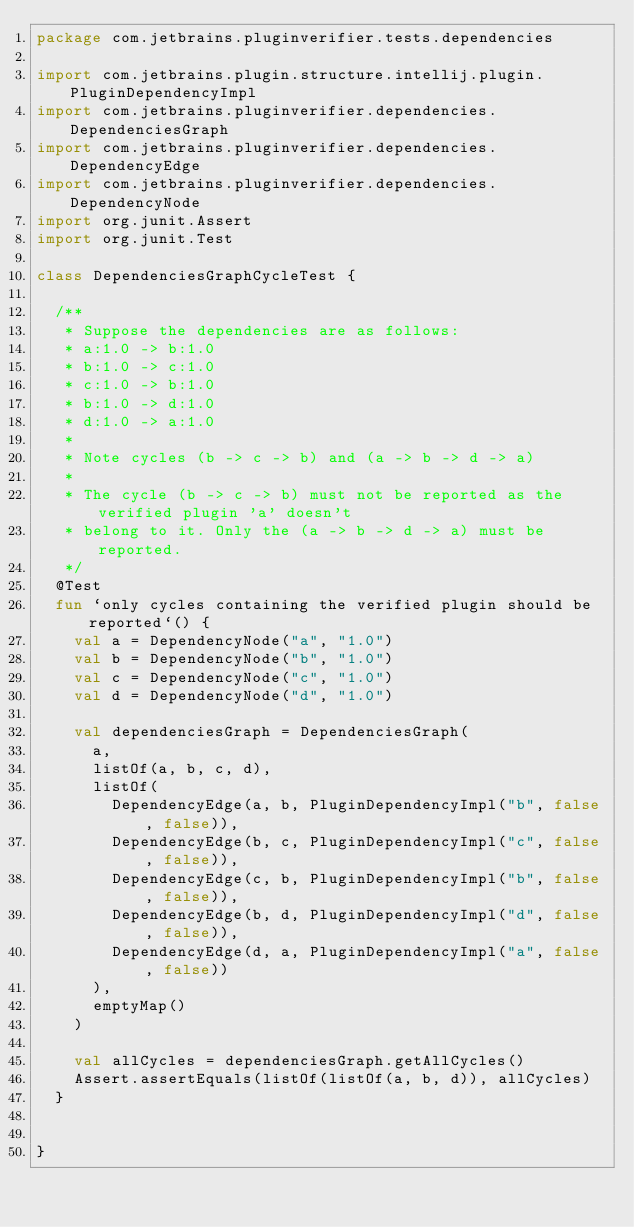Convert code to text. <code><loc_0><loc_0><loc_500><loc_500><_Kotlin_>package com.jetbrains.pluginverifier.tests.dependencies

import com.jetbrains.plugin.structure.intellij.plugin.PluginDependencyImpl
import com.jetbrains.pluginverifier.dependencies.DependenciesGraph
import com.jetbrains.pluginverifier.dependencies.DependencyEdge
import com.jetbrains.pluginverifier.dependencies.DependencyNode
import org.junit.Assert
import org.junit.Test

class DependenciesGraphCycleTest {

  /**
   * Suppose the dependencies are as follows:
   * a:1.0 -> b:1.0
   * b:1.0 -> c:1.0
   * c:1.0 -> b:1.0
   * b:1.0 -> d:1.0
   * d:1.0 -> a:1.0
   *
   * Note cycles (b -> c -> b) and (a -> b -> d -> a)
   *
   * The cycle (b -> c -> b) must not be reported as the verified plugin 'a' doesn't
   * belong to it. Only the (a -> b -> d -> a) must be reported.
   */
  @Test
  fun `only cycles containing the verified plugin should be reported`() {
    val a = DependencyNode("a", "1.0")
    val b = DependencyNode("b", "1.0")
    val c = DependencyNode("c", "1.0")
    val d = DependencyNode("d", "1.0")

    val dependenciesGraph = DependenciesGraph(
      a,
      listOf(a, b, c, d),
      listOf(
        DependencyEdge(a, b, PluginDependencyImpl("b", false, false)),
        DependencyEdge(b, c, PluginDependencyImpl("c", false, false)),
        DependencyEdge(c, b, PluginDependencyImpl("b", false, false)),
        DependencyEdge(b, d, PluginDependencyImpl("d", false, false)),
        DependencyEdge(d, a, PluginDependencyImpl("a", false, false))
      ),
      emptyMap()
    )

    val allCycles = dependenciesGraph.getAllCycles()
    Assert.assertEquals(listOf(listOf(a, b, d)), allCycles)
  }


}</code> 